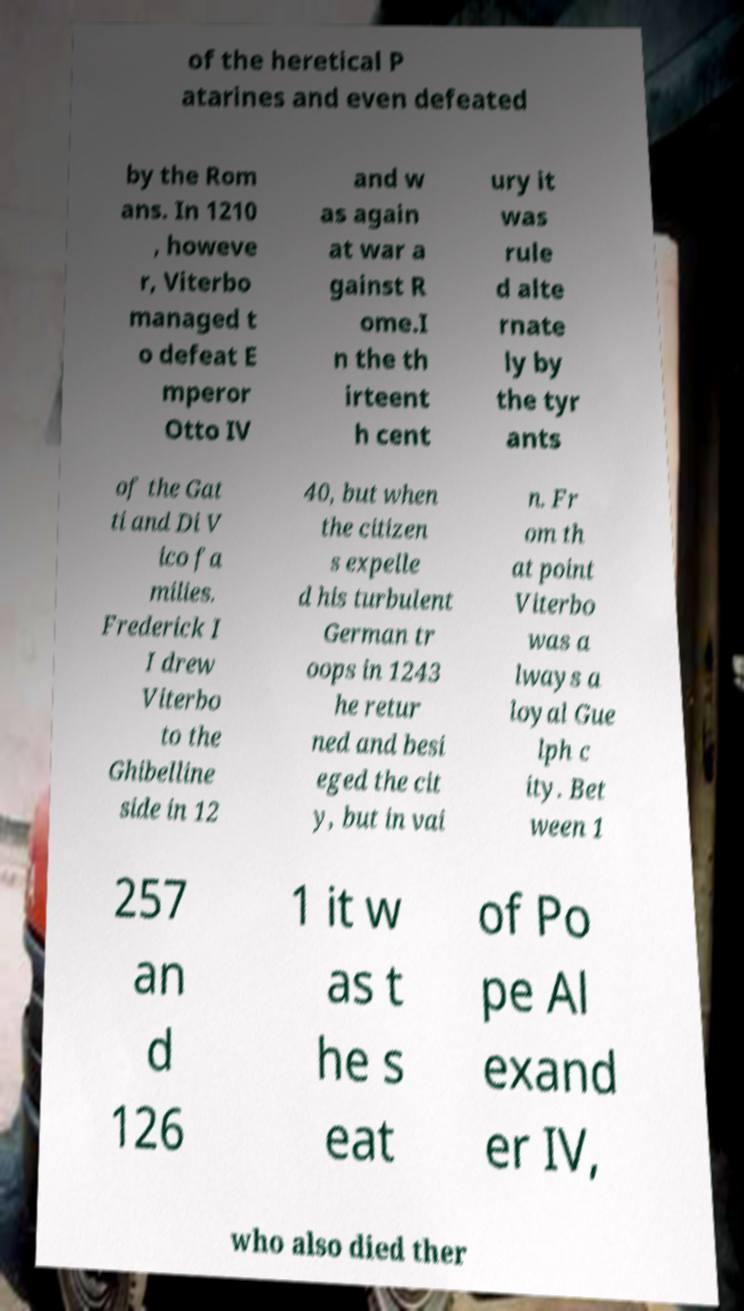Could you extract and type out the text from this image? of the heretical P atarines and even defeated by the Rom ans. In 1210 , howeve r, Viterbo managed t o defeat E mperor Otto IV and w as again at war a gainst R ome.I n the th irteent h cent ury it was rule d alte rnate ly by the tyr ants of the Gat ti and Di V ico fa milies. Frederick I I drew Viterbo to the Ghibelline side in 12 40, but when the citizen s expelle d his turbulent German tr oops in 1243 he retur ned and besi eged the cit y, but in vai n. Fr om th at point Viterbo was a lways a loyal Gue lph c ity. Bet ween 1 257 an d 126 1 it w as t he s eat of Po pe Al exand er IV, who also died ther 